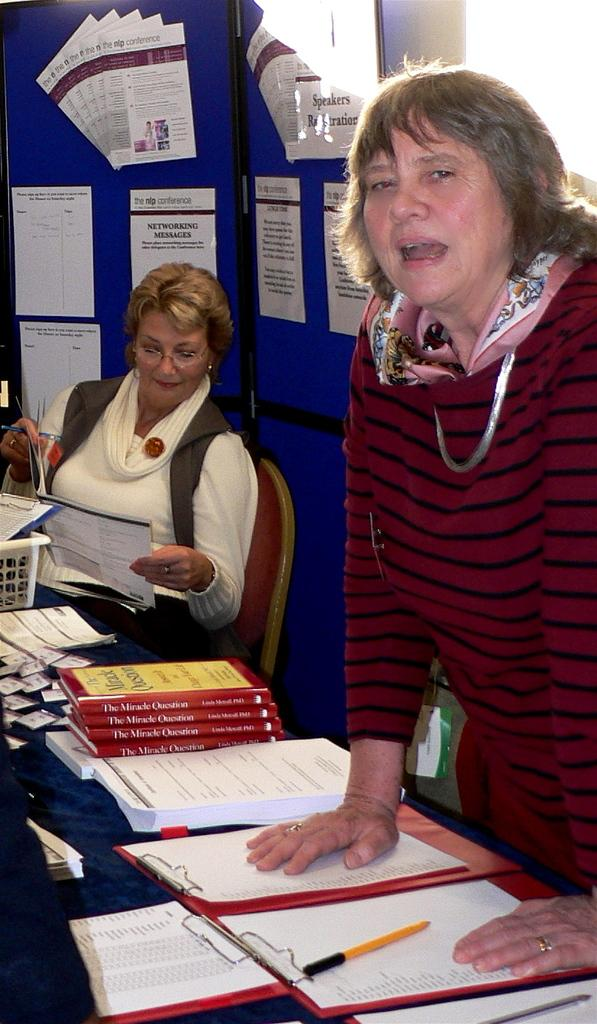<image>
Create a compact narrative representing the image presented. Two women work the registration table for the nip Conference. 